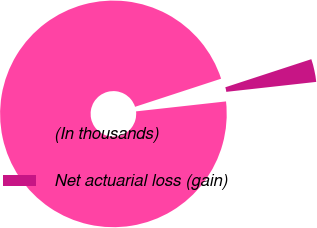<chart> <loc_0><loc_0><loc_500><loc_500><pie_chart><fcel>(In thousands)<fcel>Net actuarial loss (gain)<nl><fcel>96.73%<fcel>3.27%<nl></chart> 